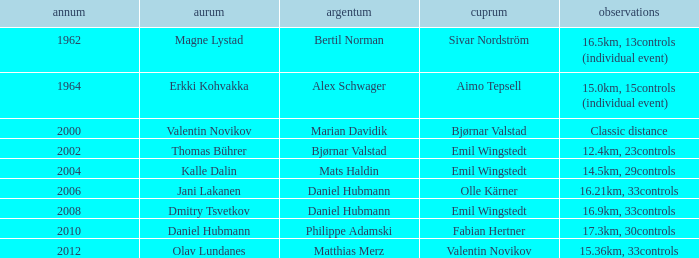WHAT IS THE SILVER WITH A YEAR OF 1962? Bertil Norman. 